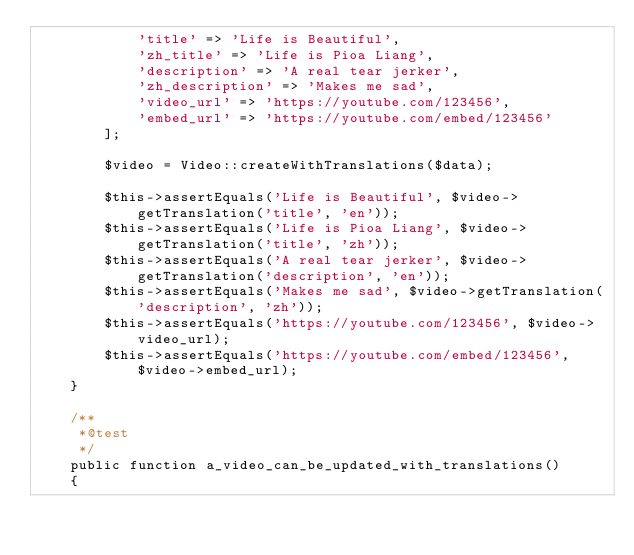<code> <loc_0><loc_0><loc_500><loc_500><_PHP_>            'title' => 'Life is Beautiful',
            'zh_title' => 'Life is Pioa Liang',
            'description' => 'A real tear jerker',
            'zh_description' => 'Makes me sad',
            'video_url' => 'https://youtube.com/123456',
            'embed_url' => 'https://youtube.com/embed/123456'
        ];

        $video = Video::createWithTranslations($data);

        $this->assertEquals('Life is Beautiful', $video->getTranslation('title', 'en'));
        $this->assertEquals('Life is Pioa Liang', $video->getTranslation('title', 'zh'));
        $this->assertEquals('A real tear jerker', $video->getTranslation('description', 'en'));
        $this->assertEquals('Makes me sad', $video->getTranslation('description', 'zh'));
        $this->assertEquals('https://youtube.com/123456', $video->video_url);
        $this->assertEquals('https://youtube.com/embed/123456', $video->embed_url);
    }

    /**
     *@test
     */
    public function a_video_can_be_updated_with_translations()
    {</code> 